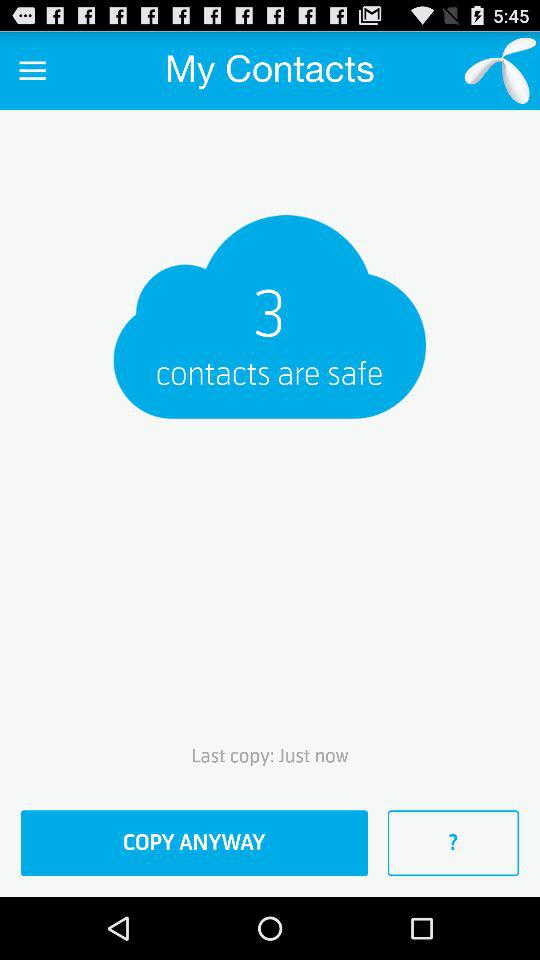When was the last contact copied? The last contact was copied just now. 